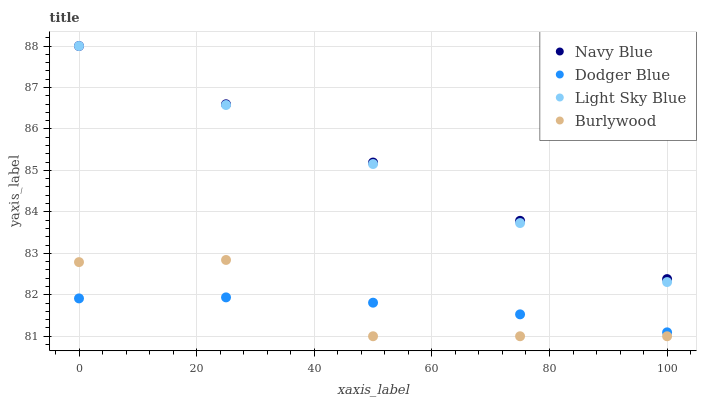Does Burlywood have the minimum area under the curve?
Answer yes or no. Yes. Does Navy Blue have the maximum area under the curve?
Answer yes or no. Yes. Does Light Sky Blue have the minimum area under the curve?
Answer yes or no. No. Does Light Sky Blue have the maximum area under the curve?
Answer yes or no. No. Is Navy Blue the smoothest?
Answer yes or no. Yes. Is Burlywood the roughest?
Answer yes or no. Yes. Is Light Sky Blue the smoothest?
Answer yes or no. No. Is Light Sky Blue the roughest?
Answer yes or no. No. Does Burlywood have the lowest value?
Answer yes or no. Yes. Does Light Sky Blue have the lowest value?
Answer yes or no. No. Does Light Sky Blue have the highest value?
Answer yes or no. Yes. Does Dodger Blue have the highest value?
Answer yes or no. No. Is Dodger Blue less than Light Sky Blue?
Answer yes or no. Yes. Is Navy Blue greater than Dodger Blue?
Answer yes or no. Yes. Does Burlywood intersect Dodger Blue?
Answer yes or no. Yes. Is Burlywood less than Dodger Blue?
Answer yes or no. No. Is Burlywood greater than Dodger Blue?
Answer yes or no. No. Does Dodger Blue intersect Light Sky Blue?
Answer yes or no. No. 